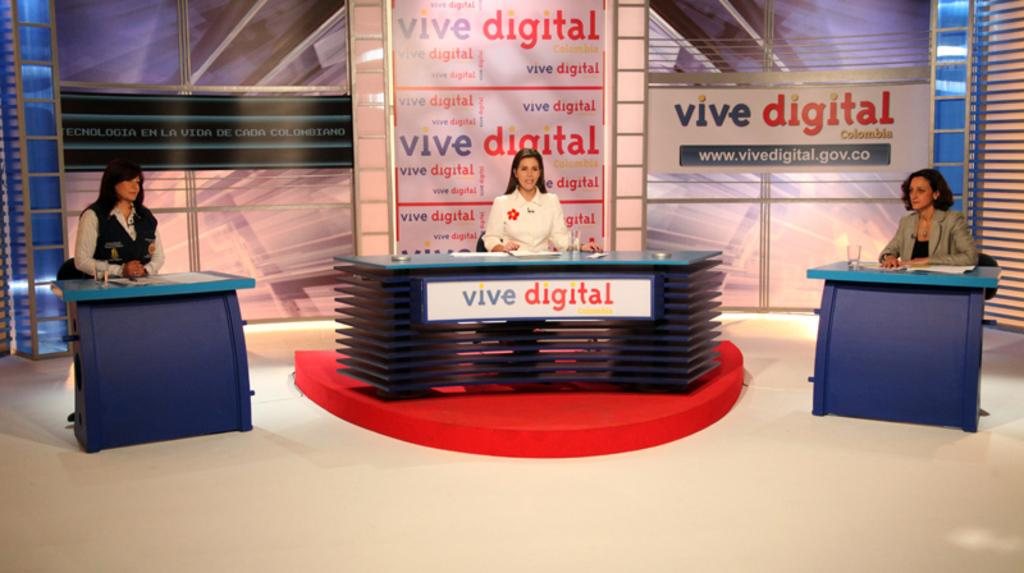How many people are in the image? There are three ladies in the image. What are the ladies doing in the image? The ladies are sitting on chairs. Where are the chairs located in relation to the desk? The chairs are in front of a desk. What type of vegetable is being used as a game piece in the image? There is no game or vegetable present in the image; it features three ladies sitting on chairs in front of a desk. 